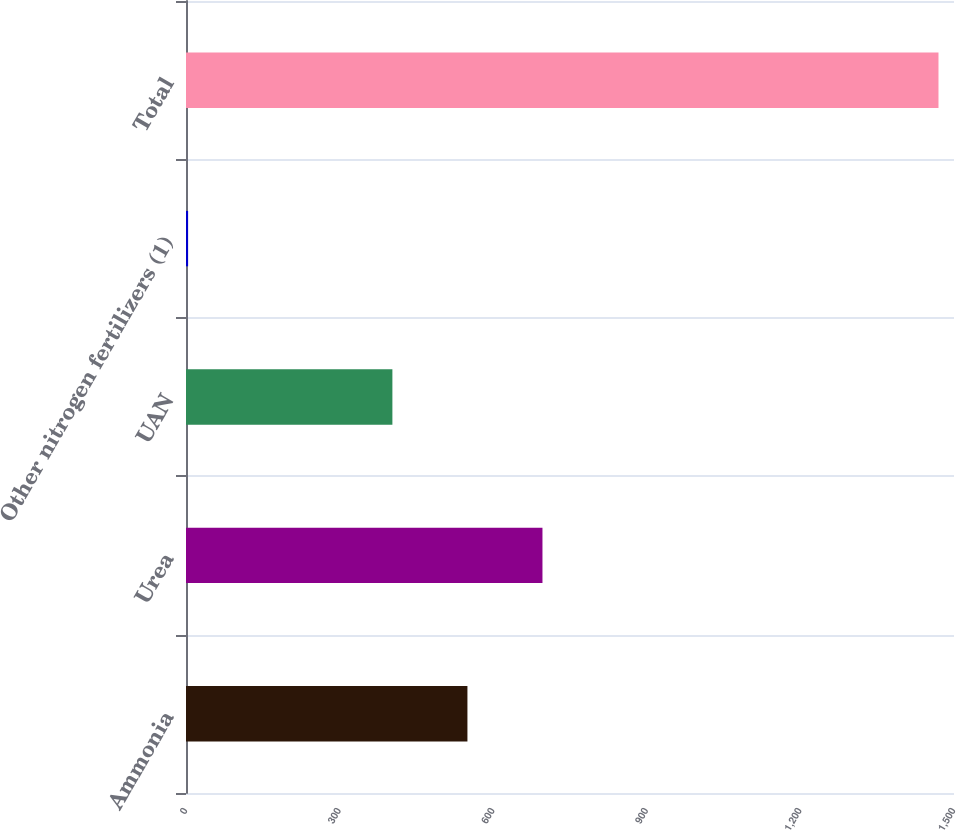<chart> <loc_0><loc_0><loc_500><loc_500><bar_chart><fcel>Ammonia<fcel>Urea<fcel>UAN<fcel>Other nitrogen fertilizers (1)<fcel>Total<nl><fcel>549.66<fcel>696.22<fcel>403.1<fcel>4.1<fcel>1469.7<nl></chart> 